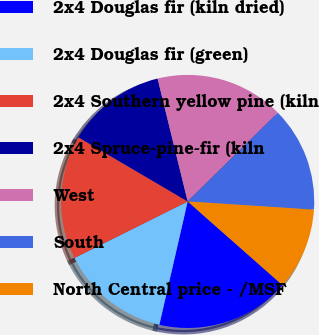<chart> <loc_0><loc_0><loc_500><loc_500><pie_chart><fcel>2x4 Douglas fir (kiln dried)<fcel>2x4 Douglas fir (green)<fcel>2x4 Southern yellow pine (kiln<fcel>2x4 Spruce-pine-fir (kiln<fcel>West<fcel>South<fcel>North Central price - /MSF<nl><fcel>17.09%<fcel>14.04%<fcel>15.81%<fcel>12.73%<fcel>16.45%<fcel>13.41%<fcel>10.47%<nl></chart> 